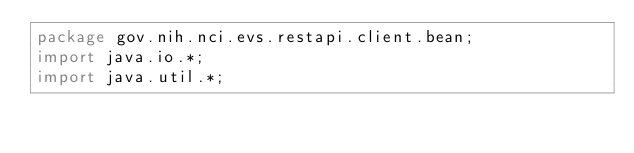Convert code to text. <code><loc_0><loc_0><loc_500><loc_500><_Java_>package gov.nih.nci.evs.restapi.client.bean;
import java.io.*;
import java.util.*;</code> 